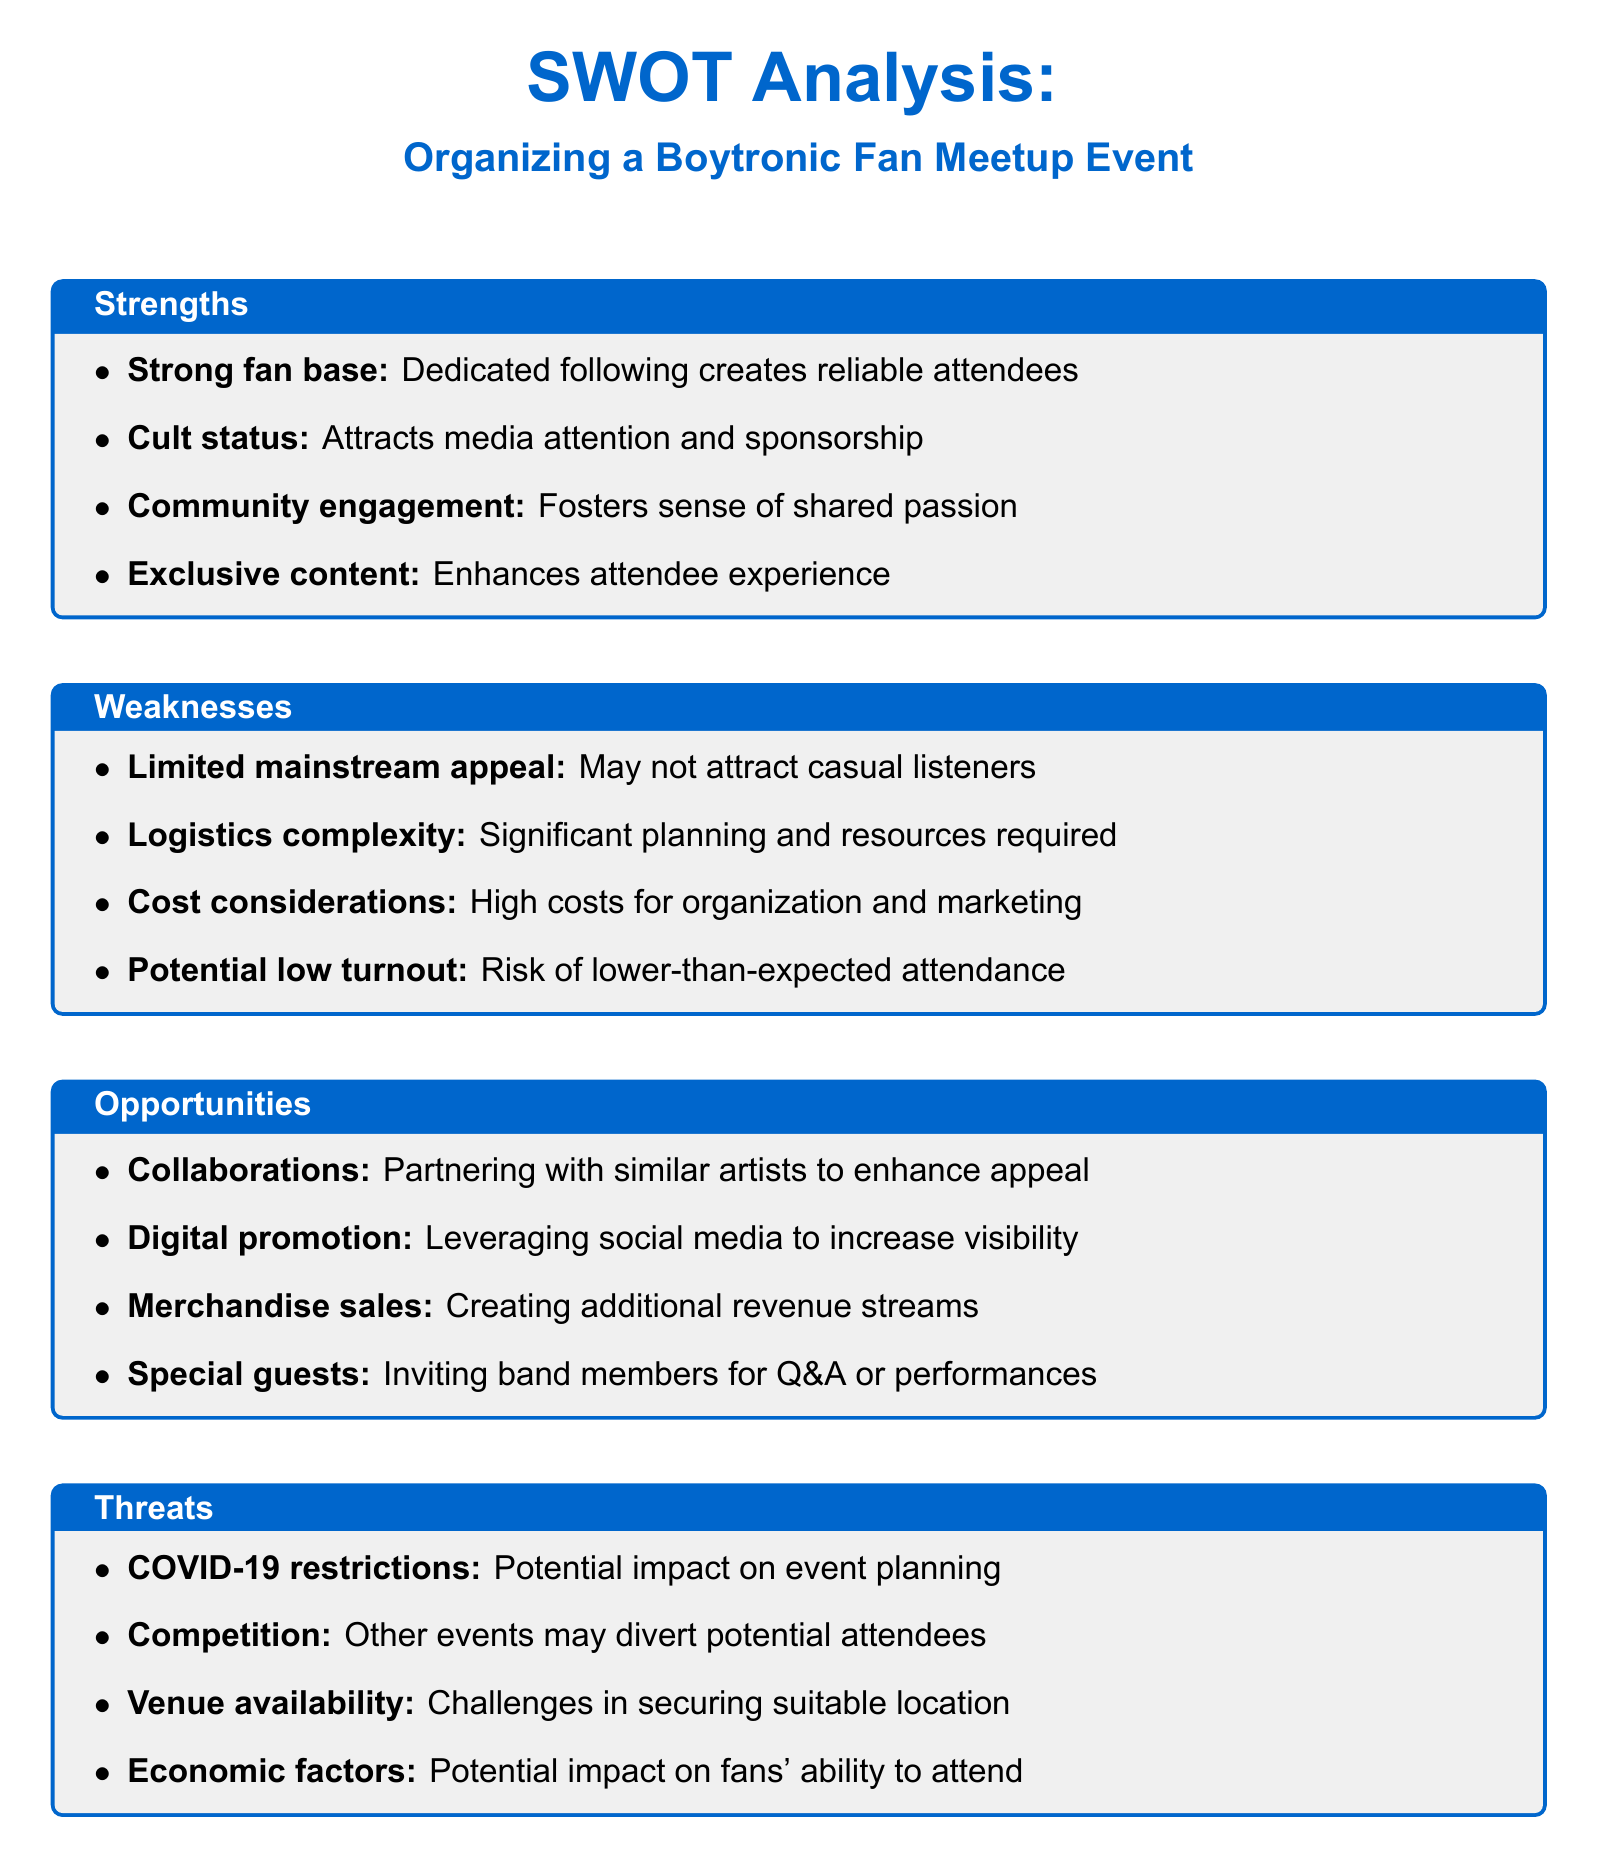What is the title of the SWOT analysis? The title provides the main focus of the SWOT analysis within the document.
Answer: Organizing a Boytronic Fan Meetup Event How many strengths are listed? The number of strengths is specified in the strengths section of the SWOT analysis.
Answer: Four What is one identified weakness? The weaknesses section mentions specific challenges associated with organizing the event.
Answer: High costs for organization and marketing Name one opportunity mentioned. The opportunities section lists various potential advantages for organizing the event.
Answer: Collaborations What is one threat listed in the document? The threats section describes factors that could negatively impact the event.
Answer: COVID-19 restrictions What color is used for the section titles? The color used consistently for section titles indicates the aesthetic choice in the document.
Answer: Boytronic blue What might indicate a strong fan base? The text describes characteristics of the fan base in the strengths section, indicating reliability.
Answer: Dedicated following How does the document categorize the analysis? The structure of the document categorizes analysis into four specific areas.
Answer: SWOT (Strengths, Weaknesses, Opportunities, Threats) What is a potential consequence of limited mainstream appeal? The document outlines what limited mainstream appeal may lead to regarding attendance.
Answer: May not attract casual listeners 